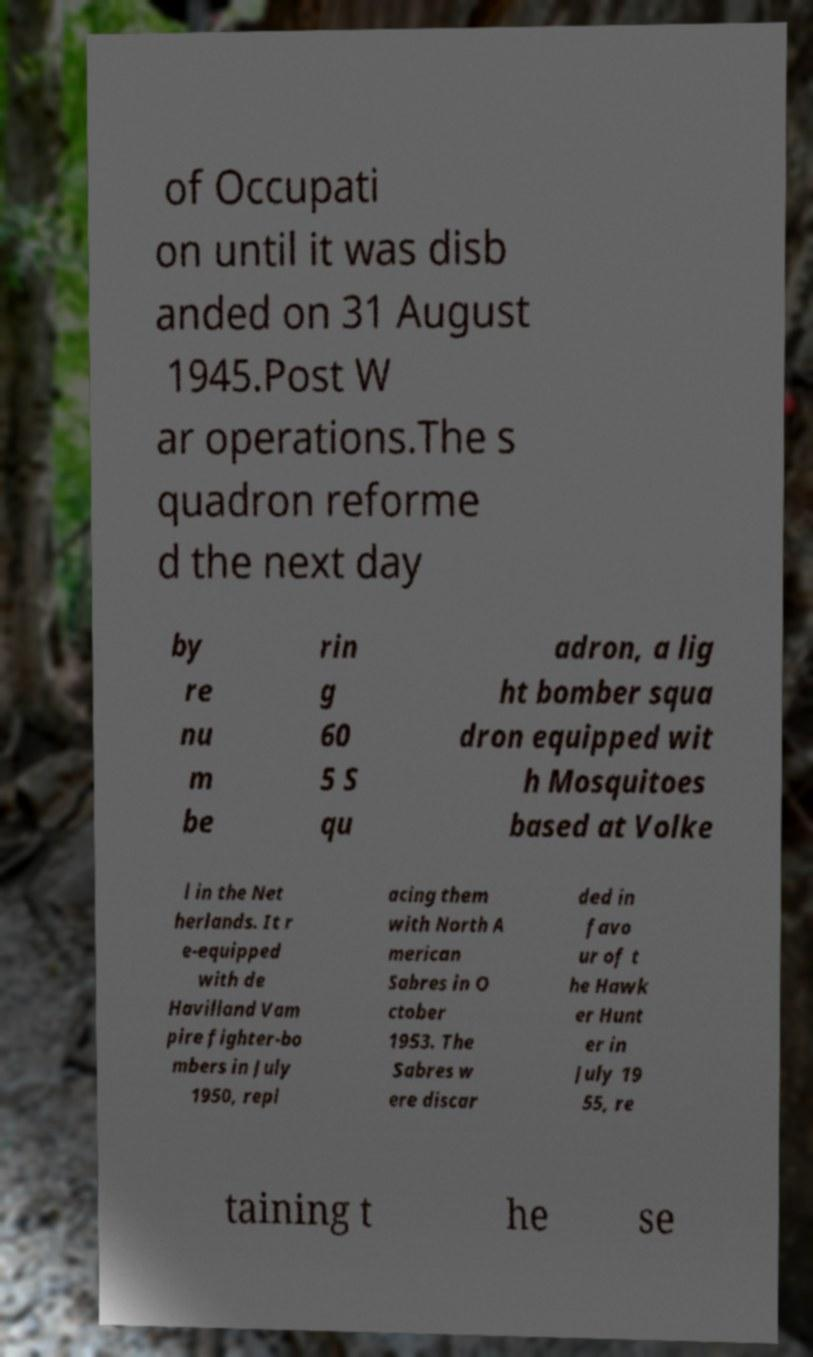Can you accurately transcribe the text from the provided image for me? of Occupati on until it was disb anded on 31 August 1945.Post W ar operations.The s quadron reforme d the next day by re nu m be rin g 60 5 S qu adron, a lig ht bomber squa dron equipped wit h Mosquitoes based at Volke l in the Net herlands. It r e-equipped with de Havilland Vam pire fighter-bo mbers in July 1950, repl acing them with North A merican Sabres in O ctober 1953. The Sabres w ere discar ded in favo ur of t he Hawk er Hunt er in July 19 55, re taining t he se 